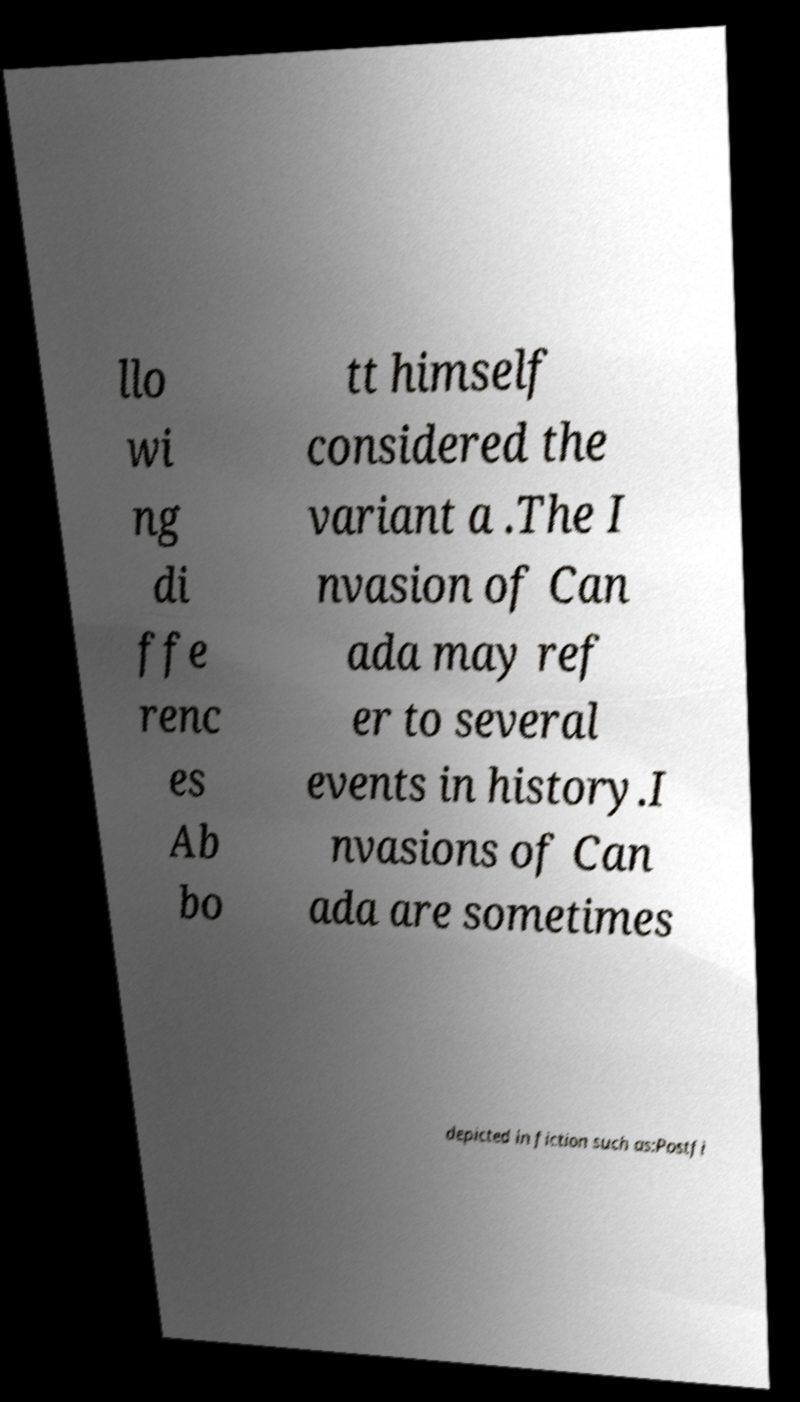I need the written content from this picture converted into text. Can you do that? llo wi ng di ffe renc es Ab bo tt himself considered the variant a .The I nvasion of Can ada may ref er to several events in history.I nvasions of Can ada are sometimes depicted in fiction such as:Postfi 